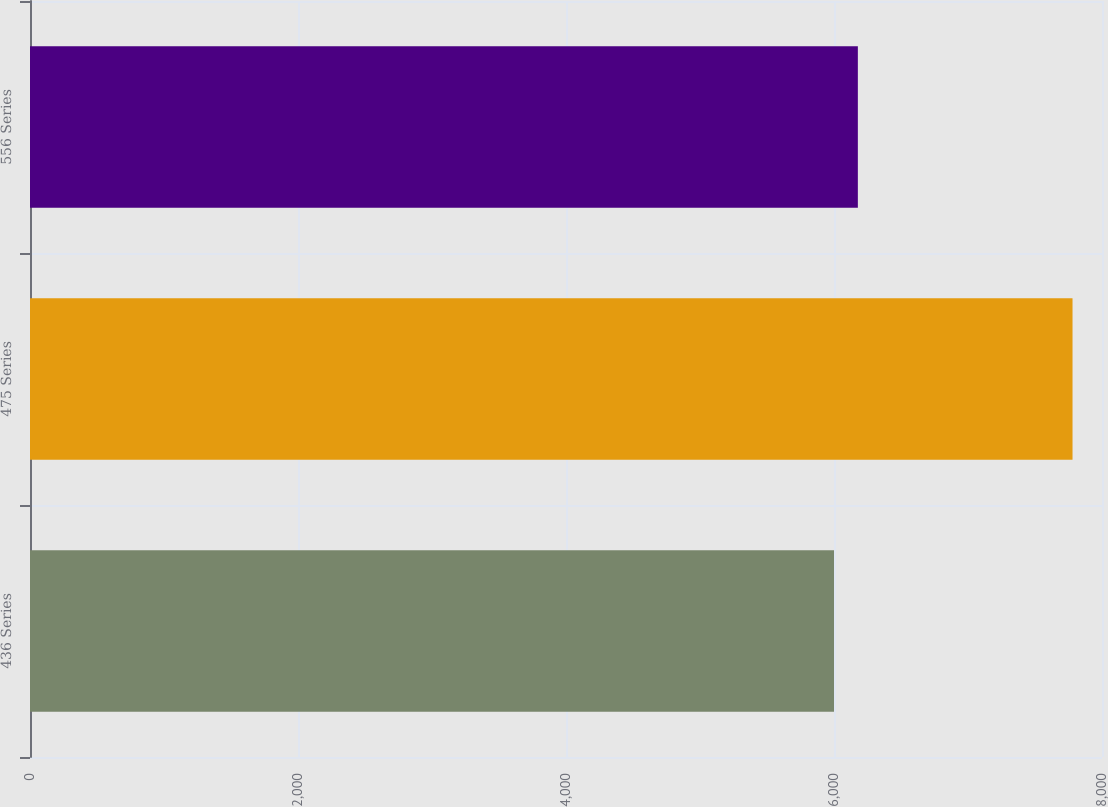Convert chart. <chart><loc_0><loc_0><loc_500><loc_500><bar_chart><fcel>436 Series<fcel>475 Series<fcel>556 Series<nl><fcel>6000<fcel>7780<fcel>6178<nl></chart> 